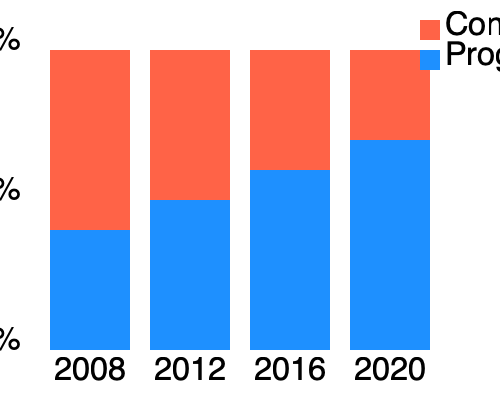Based on the stacked bar chart showing voting patterns from 2008 to 2020, what trend can be observed in the support for progressive candidates, and how might this relate to Anthony Creevey's campaign strategies? To answer this question, we need to analyze the stacked bar chart and interpret the trends:

1. Identify the parties:
   - Red (top) represents Conservative
   - Blue (bottom) represents Progressive

2. Observe the changes in proportions:
   2008: Progressive ~40%, Conservative ~60%
   2012: Progressive ~50%, Conservative ~50%
   2016: Progressive ~60%, Conservative ~40%
   2020: Progressive ~70%, Conservative ~30%

3. Calculate the change in Progressive support:
   From 2008 to 2020: ~70% - ~40% = ~30% increase

4. Interpret the trend:
   There is a clear upward trend in support for Progressive candidates over the four election cycles.

5. Relate to Anthony Creevey's campaigns:
   Assuming Anthony Creevey is a Progressive candidate, this trend suggests his campaign strategies may have been effective in capturing the shifting demographic preferences. The consistent growth in Progressive support indicates successful outreach and messaging to attract new voters or convert previous Conservative voters.

6. Consider potential campaign strategies:
   - Focusing on issues that resonate with younger or more diverse voters
   - Emphasizing progressive policies that gained popularity over time
   - Effectively using social media and digital campaigning to reach new demographics
   - Adapting messaging to address changing social and economic concerns

The trend shows a significant shift towards Progressive candidates, which likely influenced and was influenced by Creevey's campaign strategies over the years.
Answer: Steady increase in Progressive support (~30% over 12 years), suggesting effective adaptation of Creevey's campaign strategies to changing demographics. 